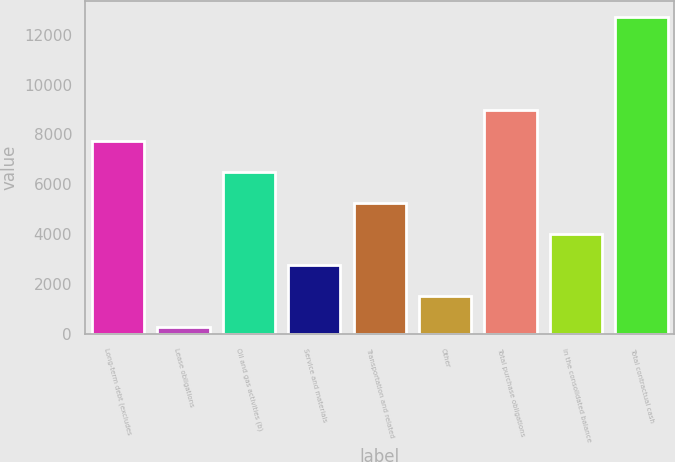<chart> <loc_0><loc_0><loc_500><loc_500><bar_chart><fcel>Long-term debt (excludes<fcel>Lease obligations<fcel>Oil and gas activities (b)<fcel>Service and materials<fcel>Transportation and related<fcel>Other<fcel>Total purchase obligations<fcel>in the consolidated balance<fcel>Total contractual cash<nl><fcel>7736.6<fcel>275<fcel>6493<fcel>2762.2<fcel>5249.4<fcel>1518.6<fcel>8980.2<fcel>4005.8<fcel>12711<nl></chart> 